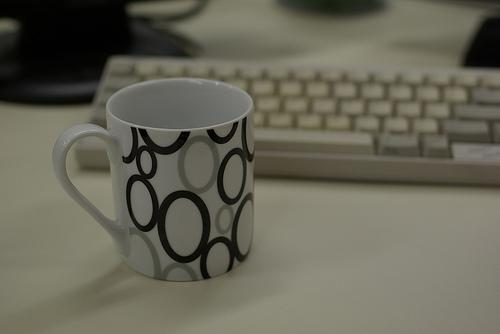How many objects are clearly visible in the image, and what are they? Three objects are clearly visible in the image: a ceramic tea cup, a white keyboard, and a black monitor. Analyze the interaction between the objects in the image. The ceramic tea cup is kept close to the keyboard, suggesting a possible break or work session with a beverage. Mention the design pattern found on the primary object and the colors involved. The design pattern on the primary object includes black and grey circles, both big and small. Estimate the visual quality of the image based on the clarity and sharpness of the objects. The visual quality of the image is moderately high, with clear depiction of objects and their details, yet some parts appear blurry. What type of electronic device is depicted next to the primary object in the image? A white plastic keyboard with numbers and letters is depicted next to the primary object. Explain any reasoning or logic that can be derived from the placement or arrangement of objects in the image. The arrangement implies that someone might be taking a break from working on their computer or has just finished their coffee while using the computer. Identify the primary object in the image, and describe its appearance. A white ceramic tea cup with black and grey circles pattern is the main object, featuring a white handle and a circular shape at the top. Can you determine the contents of the primary object, and explain its state? The primary object is an empty coffee mug, indicating that it doesn't have any coffee in it. Provide a brief emotional connotation associated with the image. The image evokes a sense of modern and minimalist style, with a touch of everyday life routine. Describe the surface where the objects are placed and provide the colors of the primary object. The objects are placed on a white table, and the primary object is a mix of white, black, and grey colors. What is the shape of the cup's top? The cup's top is circle-shaped. Describe the table's color. The table is white. Link the phrase "mug with black and grey circles" to its position in the image. The phrase refers to the ceramic tea cup that is the main object of the image, featuring circle designs in black and grey. What type of keyboard is featured in the image? A plastic keyboard with numbers and letters. Describe the color of the keyboard. The keyboard is white. What type of cup is in the image? A ceramic tea cup. Based on the image, is the cup empty or filled with a beverage? The cup is empty. What kind of art style is featured on the coffee cup? Pop art and modern art. What is the position of the keyboard in relation to the cup? The keyboard is behind the cup. What is the main object in the image, a keyboard or a teacup? A teacup What design elements are present on the coffee mug? Grey and black circles, as well as a white handle. Create a caption for the image describing the keyboard. A white legacy model keyboard with numbers and letters, sitting on a white table behind an empty ceramic coffee mug. How would you describe the mug's handle? The mug's handle is white and visible between the grey and black circles. Is the monitor in the image on or off? There isn't enough information to determine if the monitor is on or off. Identify what is near the keyboard in the image. A cup is kept near the keyboard. Choose the correct description for the ceramic item in the image: 1. Plain white teacup, 2. Black and white teacup with circle designs, 3. Blue and green teacup, 4. Transparent glass teacup. Black and white teacup with circle designs What kind of keyboard is present in the image? A white plastic legacy model keyboard. Describe the appearance of the mug in the image. A ceramic tea cup with black and white color, circle shape top, and circle art design, such as grey and black circles. 